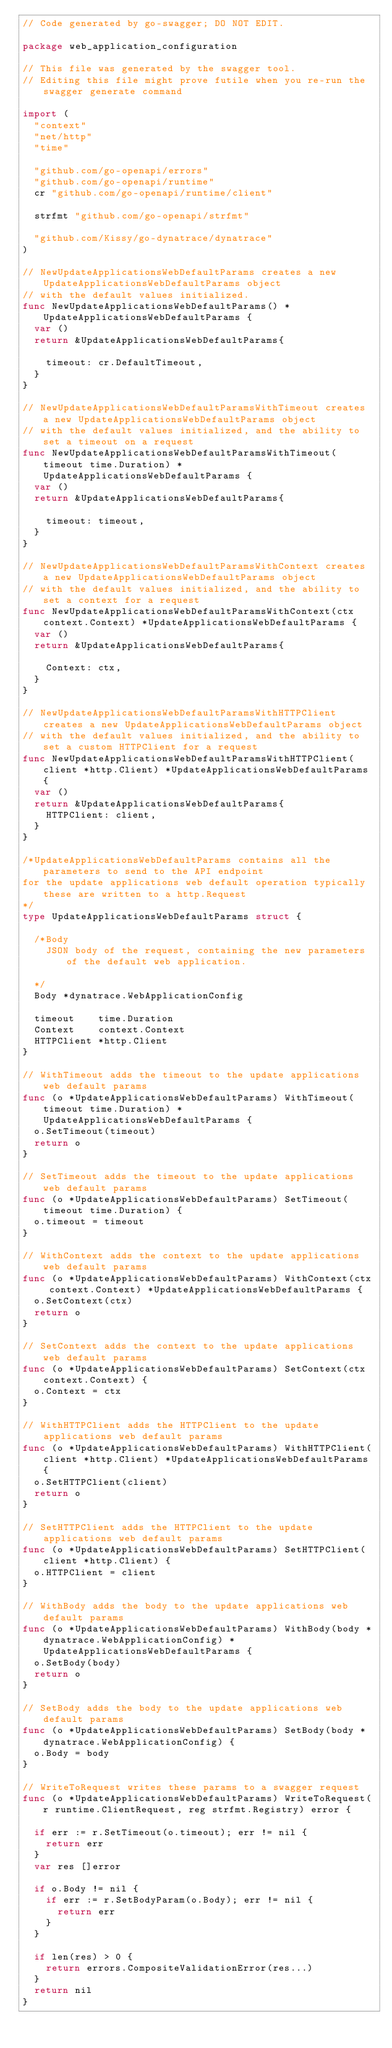<code> <loc_0><loc_0><loc_500><loc_500><_Go_>// Code generated by go-swagger; DO NOT EDIT.

package web_application_configuration

// This file was generated by the swagger tool.
// Editing this file might prove futile when you re-run the swagger generate command

import (
	"context"
	"net/http"
	"time"

	"github.com/go-openapi/errors"
	"github.com/go-openapi/runtime"
	cr "github.com/go-openapi/runtime/client"

	strfmt "github.com/go-openapi/strfmt"

	"github.com/Kissy/go-dynatrace/dynatrace"
)

// NewUpdateApplicationsWebDefaultParams creates a new UpdateApplicationsWebDefaultParams object
// with the default values initialized.
func NewUpdateApplicationsWebDefaultParams() *UpdateApplicationsWebDefaultParams {
	var ()
	return &UpdateApplicationsWebDefaultParams{

		timeout: cr.DefaultTimeout,
	}
}

// NewUpdateApplicationsWebDefaultParamsWithTimeout creates a new UpdateApplicationsWebDefaultParams object
// with the default values initialized, and the ability to set a timeout on a request
func NewUpdateApplicationsWebDefaultParamsWithTimeout(timeout time.Duration) *UpdateApplicationsWebDefaultParams {
	var ()
	return &UpdateApplicationsWebDefaultParams{

		timeout: timeout,
	}
}

// NewUpdateApplicationsWebDefaultParamsWithContext creates a new UpdateApplicationsWebDefaultParams object
// with the default values initialized, and the ability to set a context for a request
func NewUpdateApplicationsWebDefaultParamsWithContext(ctx context.Context) *UpdateApplicationsWebDefaultParams {
	var ()
	return &UpdateApplicationsWebDefaultParams{

		Context: ctx,
	}
}

// NewUpdateApplicationsWebDefaultParamsWithHTTPClient creates a new UpdateApplicationsWebDefaultParams object
// with the default values initialized, and the ability to set a custom HTTPClient for a request
func NewUpdateApplicationsWebDefaultParamsWithHTTPClient(client *http.Client) *UpdateApplicationsWebDefaultParams {
	var ()
	return &UpdateApplicationsWebDefaultParams{
		HTTPClient: client,
	}
}

/*UpdateApplicationsWebDefaultParams contains all the parameters to send to the API endpoint
for the update applications web default operation typically these are written to a http.Request
*/
type UpdateApplicationsWebDefaultParams struct {

	/*Body
	  JSON body of the request, containing the new parameters of the default web application.

	*/
	Body *dynatrace.WebApplicationConfig

	timeout    time.Duration
	Context    context.Context
	HTTPClient *http.Client
}

// WithTimeout adds the timeout to the update applications web default params
func (o *UpdateApplicationsWebDefaultParams) WithTimeout(timeout time.Duration) *UpdateApplicationsWebDefaultParams {
	o.SetTimeout(timeout)
	return o
}

// SetTimeout adds the timeout to the update applications web default params
func (o *UpdateApplicationsWebDefaultParams) SetTimeout(timeout time.Duration) {
	o.timeout = timeout
}

// WithContext adds the context to the update applications web default params
func (o *UpdateApplicationsWebDefaultParams) WithContext(ctx context.Context) *UpdateApplicationsWebDefaultParams {
	o.SetContext(ctx)
	return o
}

// SetContext adds the context to the update applications web default params
func (o *UpdateApplicationsWebDefaultParams) SetContext(ctx context.Context) {
	o.Context = ctx
}

// WithHTTPClient adds the HTTPClient to the update applications web default params
func (o *UpdateApplicationsWebDefaultParams) WithHTTPClient(client *http.Client) *UpdateApplicationsWebDefaultParams {
	o.SetHTTPClient(client)
	return o
}

// SetHTTPClient adds the HTTPClient to the update applications web default params
func (o *UpdateApplicationsWebDefaultParams) SetHTTPClient(client *http.Client) {
	o.HTTPClient = client
}

// WithBody adds the body to the update applications web default params
func (o *UpdateApplicationsWebDefaultParams) WithBody(body *dynatrace.WebApplicationConfig) *UpdateApplicationsWebDefaultParams {
	o.SetBody(body)
	return o
}

// SetBody adds the body to the update applications web default params
func (o *UpdateApplicationsWebDefaultParams) SetBody(body *dynatrace.WebApplicationConfig) {
	o.Body = body
}

// WriteToRequest writes these params to a swagger request
func (o *UpdateApplicationsWebDefaultParams) WriteToRequest(r runtime.ClientRequest, reg strfmt.Registry) error {

	if err := r.SetTimeout(o.timeout); err != nil {
		return err
	}
	var res []error

	if o.Body != nil {
		if err := r.SetBodyParam(o.Body); err != nil {
			return err
		}
	}

	if len(res) > 0 {
		return errors.CompositeValidationError(res...)
	}
	return nil
}
</code> 